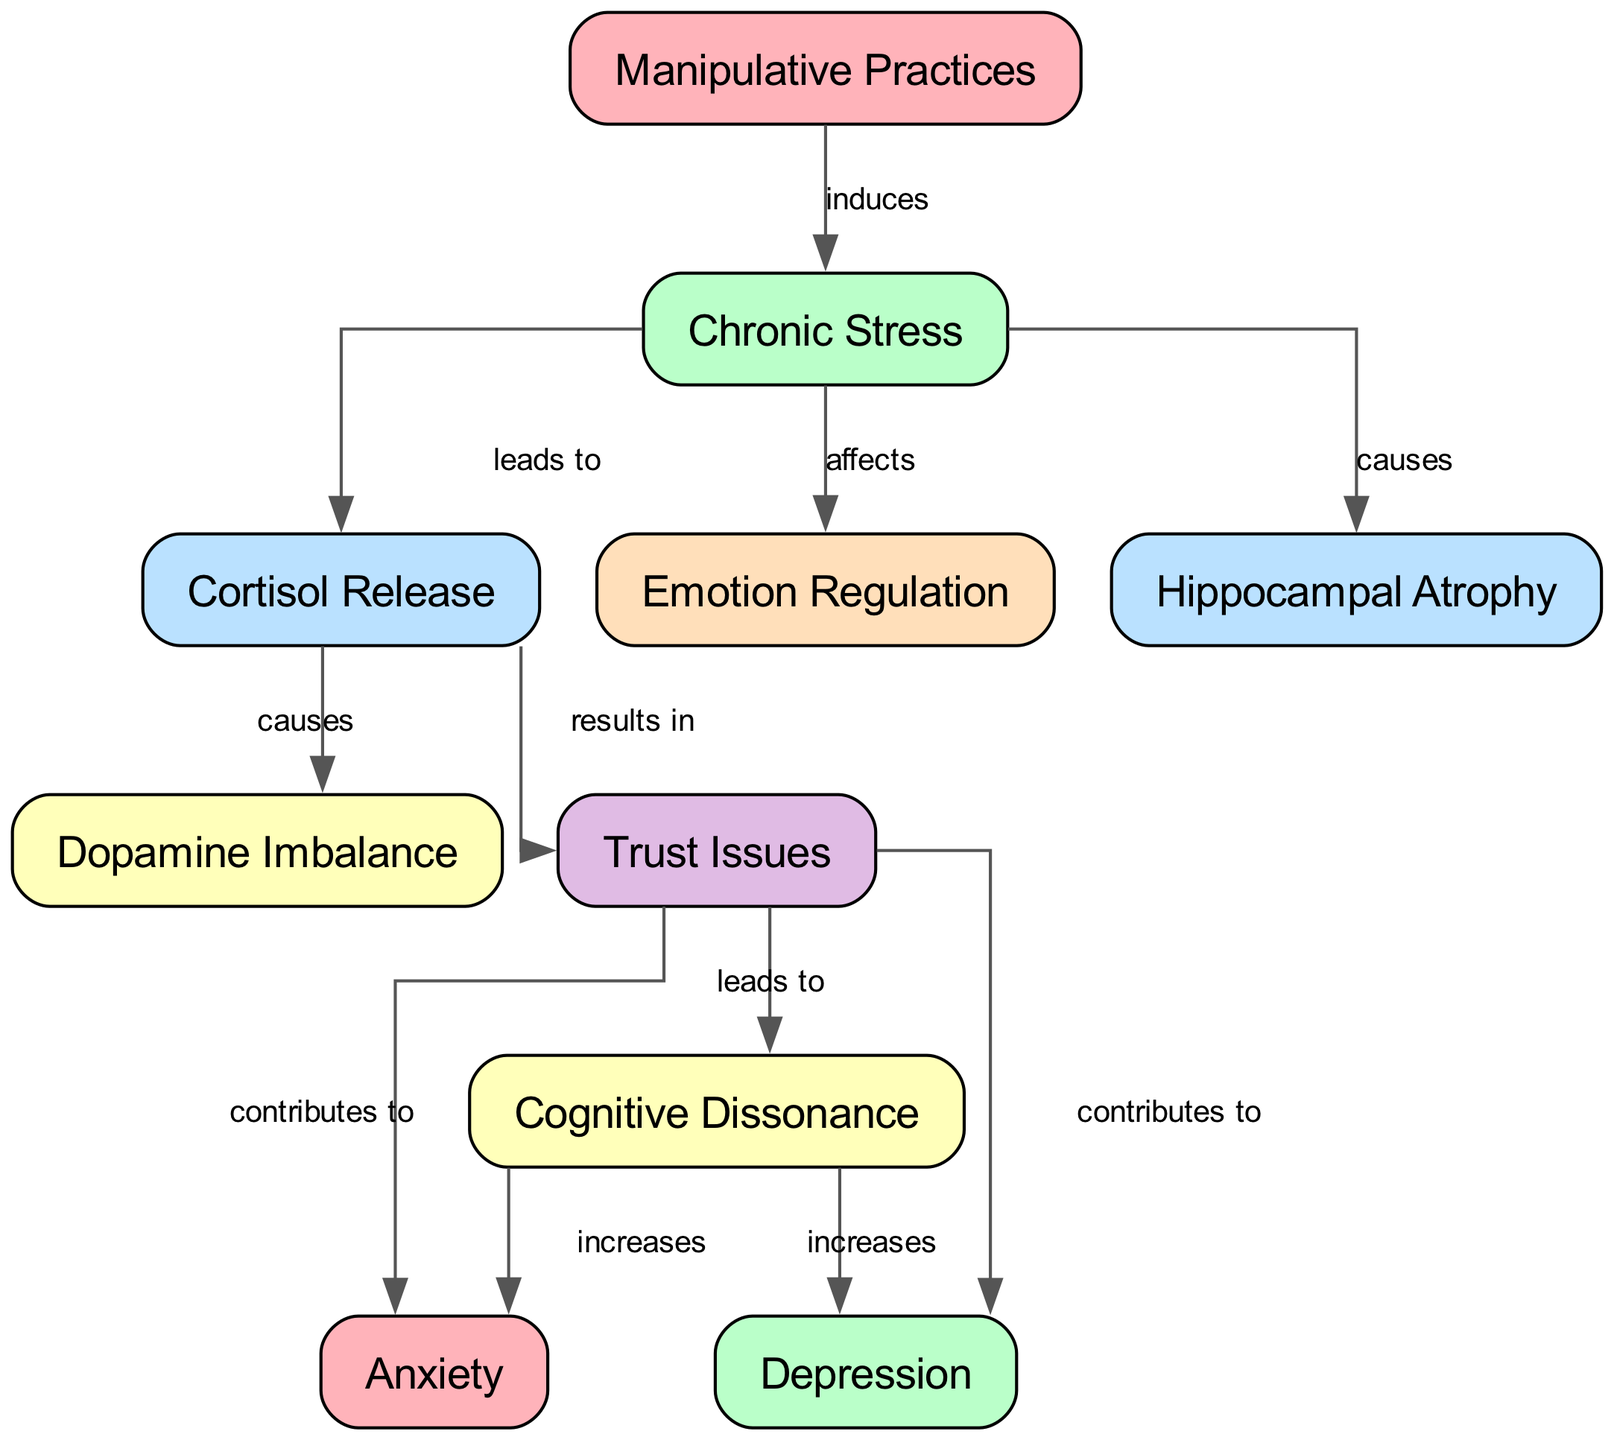What is the starting point of the diagram? The starting point of the diagram is the node labeled "Manipulative Practices," which is the first node listed.
Answer: Manipulative Practices How many total nodes are present in the diagram? By counting the "nodes" array provided, there are 10 nodes in total.
Answer: 10 What is the relationship between "Chronic Stress" and "Cortisol Release"? The label of the edge from "Chronic Stress" to "Cortisol Release" is "leads to," indicating a direct connection between these two nodes.
Answer: leads to Which node does "Trust Issues" contribute to? "Trust Issues" contributes to both "Anxiety" and "Depression," demonstrated by two edges stemming from "Trust Issues."
Answer: Anxiety, Depression What effect does "Cortisol Release" have on "Dopamine Imbalance"? The diagram shows that "Cortisol Release" causes "Dopamine Imbalance," as indicated by the arrow and label connecting these two nodes.
Answer: causes What node is affected by both "Chronic Stress" and "Manipulative Practices"? "Chronic Stress" and "Manipulative Practices" both influence "Hippocampal Atrophy," as shown by their respective edges leading directly to this node.
Answer: Hippocampal Atrophy What is the ultimate effect of "Cognitive Dissonance" on "Depression"? "Cognitive Dissonance" increases "Depression," according to the edge labeled "increases" connecting these two nodes.
Answer: increases Which two nodes experience an increase due to "Cognitive Dissonance"? The two nodes that experience an increase due to "Cognitive Dissonance" are "Anxiety" and "Depression," as both nodes are depicted with edges pointing to them from "Cognitive Dissonance."
Answer: Anxiety, Depression What emotional state is affected by "Emotion Regulation"? "Emotion Regulation" is affected by "Chronic Stress," which plays a role in how emotions are managed according to the diagram's connections.
Answer: affects 